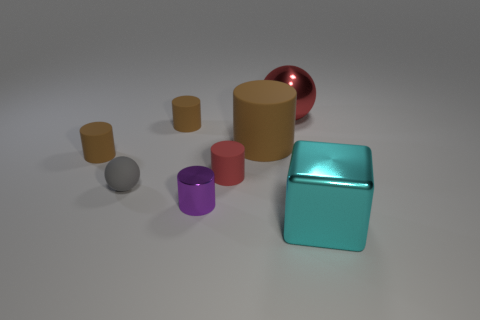Subtract all cyan cylinders. Subtract all green blocks. How many cylinders are left? 5 Subtract all yellow spheres. How many purple cubes are left? 0 Add 5 big things. How many large cyans exist? 0 Subtract all large cyan metallic balls. Subtract all brown cylinders. How many objects are left? 5 Add 3 purple metallic things. How many purple metallic things are left? 4 Add 7 big blue metal cylinders. How many big blue metal cylinders exist? 7 Add 1 big metal objects. How many objects exist? 9 Subtract all red cylinders. How many cylinders are left? 4 Subtract all large cylinders. How many cylinders are left? 4 Subtract 0 purple cubes. How many objects are left? 8 